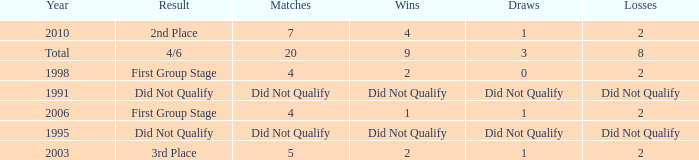What was the result for the team with 3 draws? 4/6. 